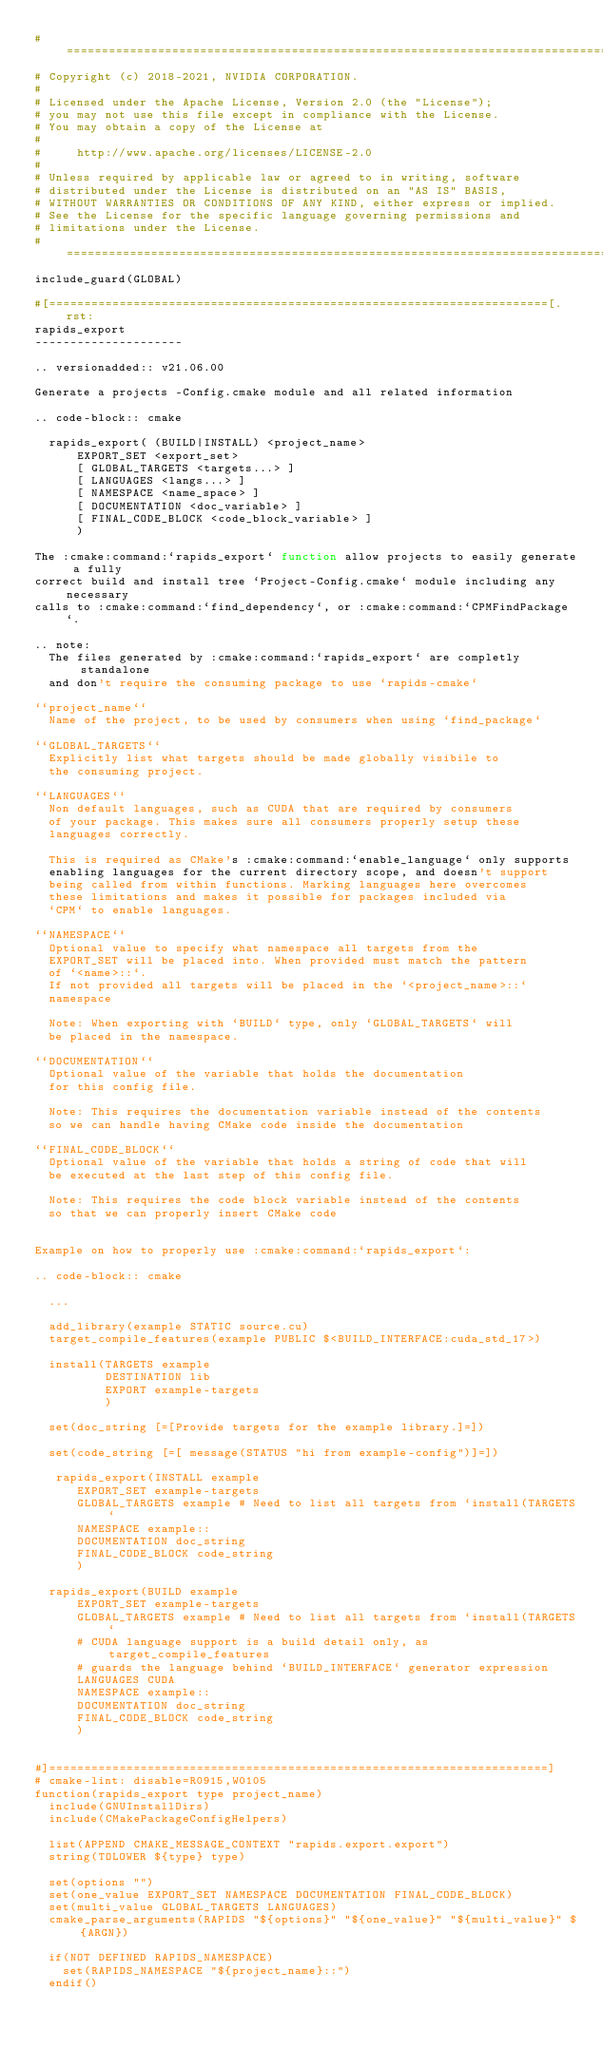<code> <loc_0><loc_0><loc_500><loc_500><_CMake_>#=============================================================================
# Copyright (c) 2018-2021, NVIDIA CORPORATION.
#
# Licensed under the Apache License, Version 2.0 (the "License");
# you may not use this file except in compliance with the License.
# You may obtain a copy of the License at
#
#     http://www.apache.org/licenses/LICENSE-2.0
#
# Unless required by applicable law or agreed to in writing, software
# distributed under the License is distributed on an "AS IS" BASIS,
# WITHOUT WARRANTIES OR CONDITIONS OF ANY KIND, either express or implied.
# See the License for the specific language governing permissions and
# limitations under the License.
#=============================================================================
include_guard(GLOBAL)

#[=======================================================================[.rst:
rapids_export
---------------------

.. versionadded:: v21.06.00

Generate a projects -Config.cmake module and all related information

.. code-block:: cmake

  rapids_export( (BUILD|INSTALL) <project_name>
      EXPORT_SET <export_set>
      [ GLOBAL_TARGETS <targets...> ]
      [ LANGUAGES <langs...> ]
      [ NAMESPACE <name_space> ]
      [ DOCUMENTATION <doc_variable> ]
      [ FINAL_CODE_BLOCK <code_block_variable> ]
      )

The :cmake:command:`rapids_export` function allow projects to easily generate a fully
correct build and install tree `Project-Config.cmake` module including any necessary
calls to :cmake:command:`find_dependency`, or :cmake:command:`CPMFindPackage`.

.. note:
  The files generated by :cmake:command:`rapids_export` are completly standalone
  and don't require the consuming package to use `rapids-cmake`

``project_name``
  Name of the project, to be used by consumers when using `find_package`

``GLOBAL_TARGETS``
  Explicitly list what targets should be made globally visibile to
  the consuming project.

``LANGUAGES``
  Non default languages, such as CUDA that are required by consumers
  of your package. This makes sure all consumers properly setup these
  languages correctly.

  This is required as CMake's :cmake:command:`enable_language` only supports
  enabling languages for the current directory scope, and doesn't support
  being called from within functions. Marking languages here overcomes
  these limitations and makes it possible for packages included via
  `CPM` to enable languages.

``NAMESPACE``
  Optional value to specify what namespace all targets from the
  EXPORT_SET will be placed into. When provided must match the pattern
  of `<name>::`.
  If not provided all targets will be placed in the `<project_name>::`
  namespace

  Note: When exporting with `BUILD` type, only `GLOBAL_TARGETS` will
  be placed in the namespace.

``DOCUMENTATION``
  Optional value of the variable that holds the documentation
  for this config file.

  Note: This requires the documentation variable instead of the contents
  so we can handle having CMake code inside the documentation

``FINAL_CODE_BLOCK``
  Optional value of the variable that holds a string of code that will
  be executed at the last step of this config file.

  Note: This requires the code block variable instead of the contents
  so that we can properly insert CMake code


Example on how to properly use :cmake:command:`rapids_export`:

.. code-block:: cmake

  ...

  add_library(example STATIC source.cu)
  target_compile_features(example PUBLIC $<BUILD_INTERFACE:cuda_std_17>)

  install(TARGETS example
          DESTINATION lib
          EXPORT example-targets
          )

  set(doc_string [=[Provide targets for the example library.]=])

  set(code_string [=[ message(STATUS "hi from example-config")]=])

   rapids_export(INSTALL example
      EXPORT_SET example-targets
      GLOBAL_TARGETS example # Need to list all targets from `install(TARGETS`
      NAMESPACE example::
      DOCUMENTATION doc_string
      FINAL_CODE_BLOCK code_string
      )

  rapids_export(BUILD example
      EXPORT_SET example-targets
      GLOBAL_TARGETS example # Need to list all targets from `install(TARGETS`
      # CUDA language support is a build detail only, as target_compile_features
      # guards the language behind `BUILD_INTERFACE` generator expression
      LANGUAGES CUDA
      NAMESPACE example::
      DOCUMENTATION doc_string
      FINAL_CODE_BLOCK code_string
      )


#]=======================================================================]
# cmake-lint: disable=R0915,W0105
function(rapids_export type project_name)
  include(GNUInstallDirs)
  include(CMakePackageConfigHelpers)

  list(APPEND CMAKE_MESSAGE_CONTEXT "rapids.export.export")
  string(TOLOWER ${type} type)

  set(options "")
  set(one_value EXPORT_SET NAMESPACE DOCUMENTATION FINAL_CODE_BLOCK)
  set(multi_value GLOBAL_TARGETS LANGUAGES)
  cmake_parse_arguments(RAPIDS "${options}" "${one_value}" "${multi_value}" ${ARGN})

  if(NOT DEFINED RAPIDS_NAMESPACE)
    set(RAPIDS_NAMESPACE "${project_name}::")
  endif()
</code> 